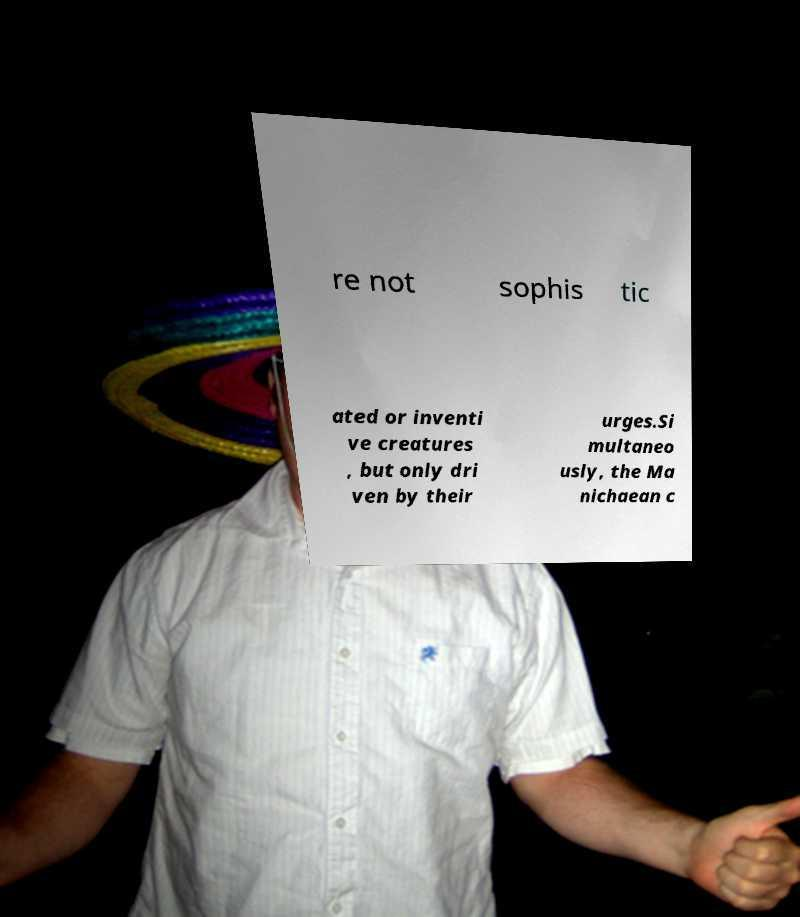There's text embedded in this image that I need extracted. Can you transcribe it verbatim? re not sophis tic ated or inventi ve creatures , but only dri ven by their urges.Si multaneo usly, the Ma nichaean c 